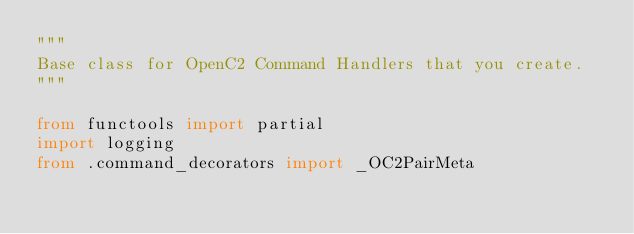<code> <loc_0><loc_0><loc_500><loc_500><_Python_>"""
Base class for OpenC2 Command Handlers that you create.
"""

from functools import partial
import logging
from .command_decorators import _OC2PairMeta</code> 